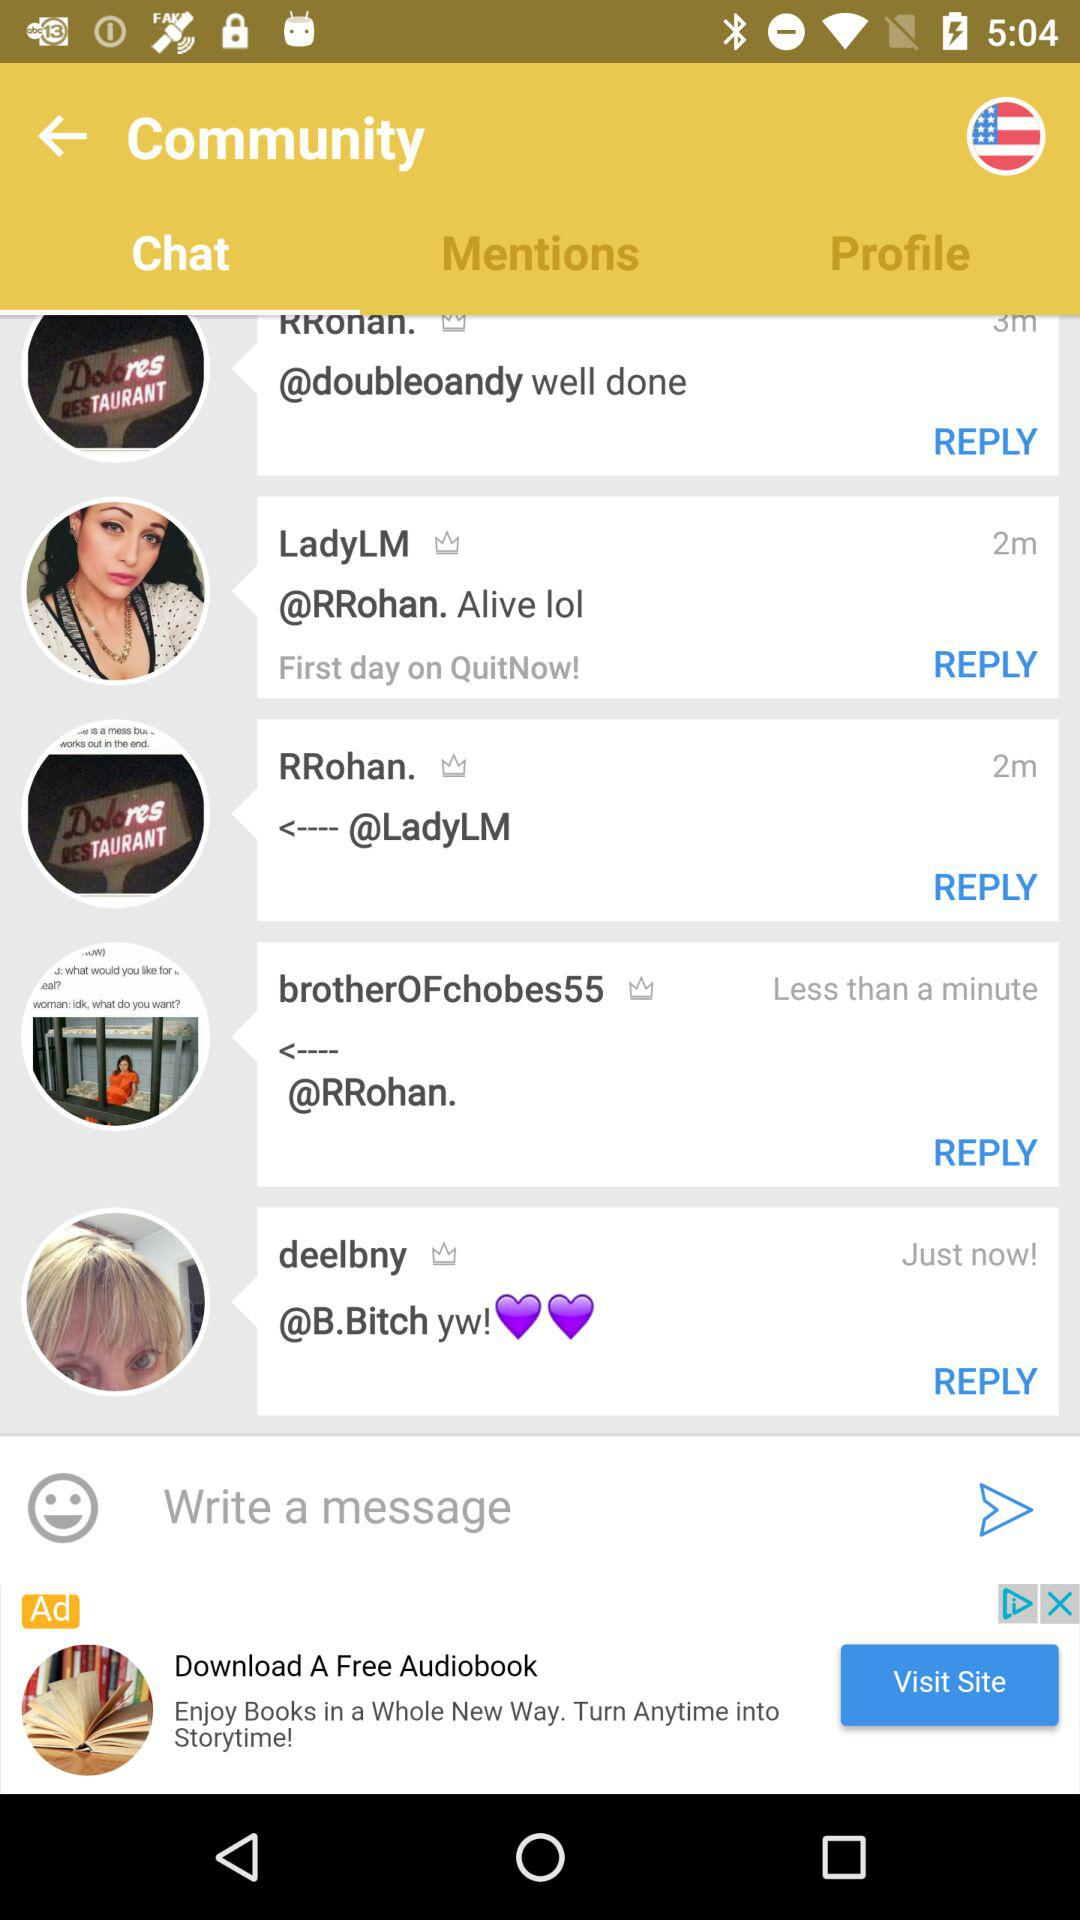How long ago did "LadyLM" message? "LadyLM" messaged 2 minutes ago. 